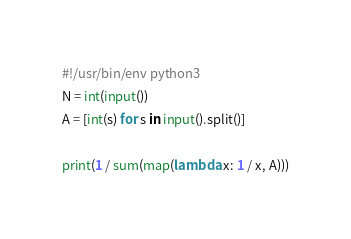Convert code to text. <code><loc_0><loc_0><loc_500><loc_500><_Python_>#!/usr/bin/env python3
N = int(input())
A = [int(s) for s in input().split()]

print(1 / sum(map(lambda x: 1 / x, A)))
</code> 